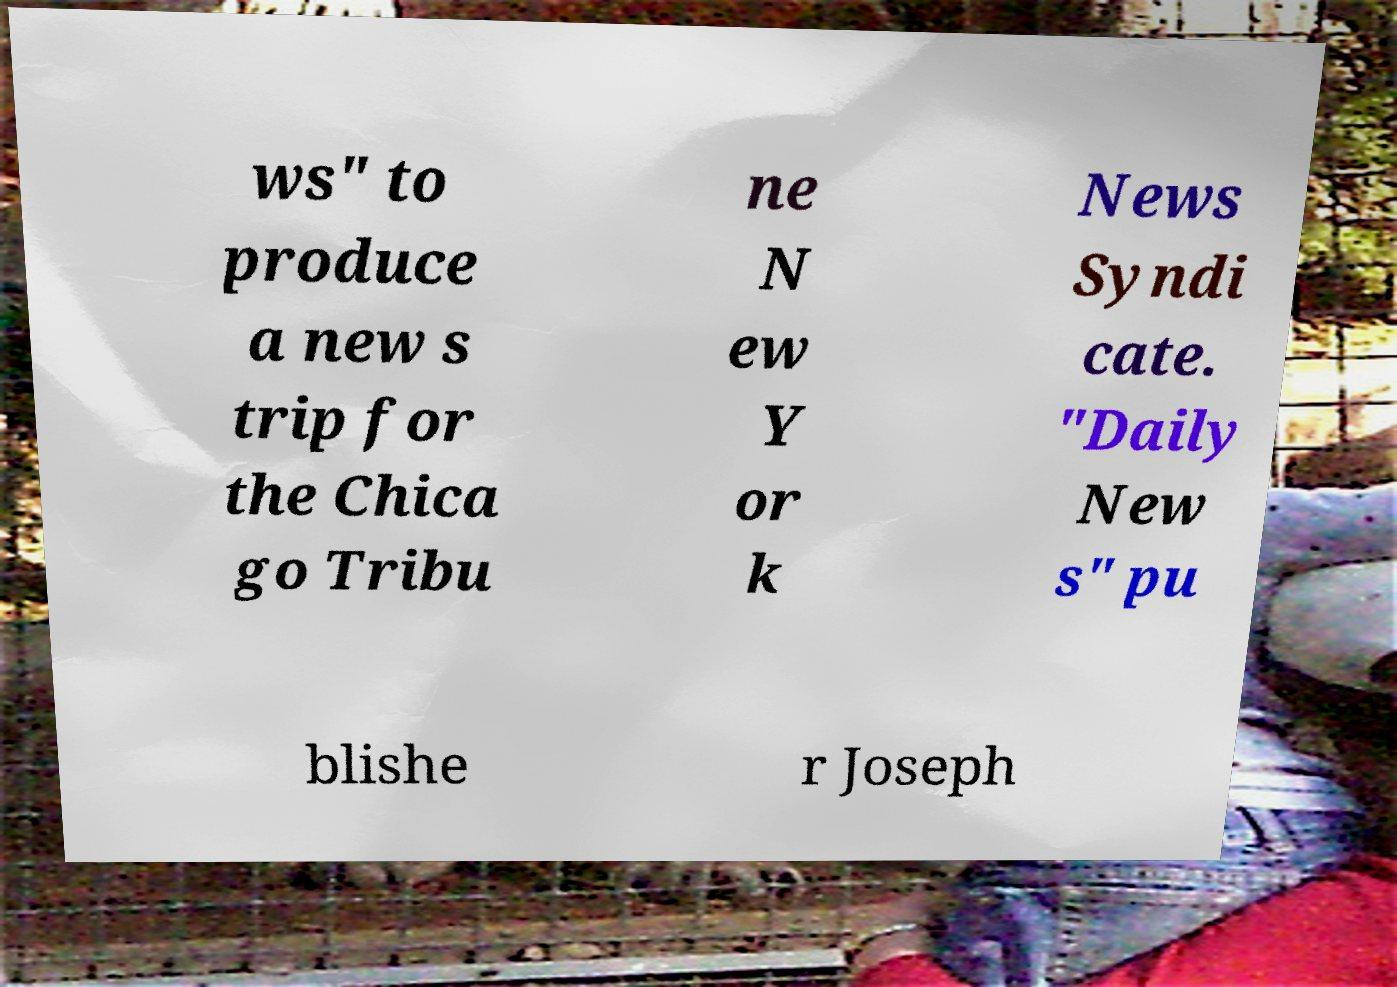Can you accurately transcribe the text from the provided image for me? ws" to produce a new s trip for the Chica go Tribu ne N ew Y or k News Syndi cate. "Daily New s" pu blishe r Joseph 